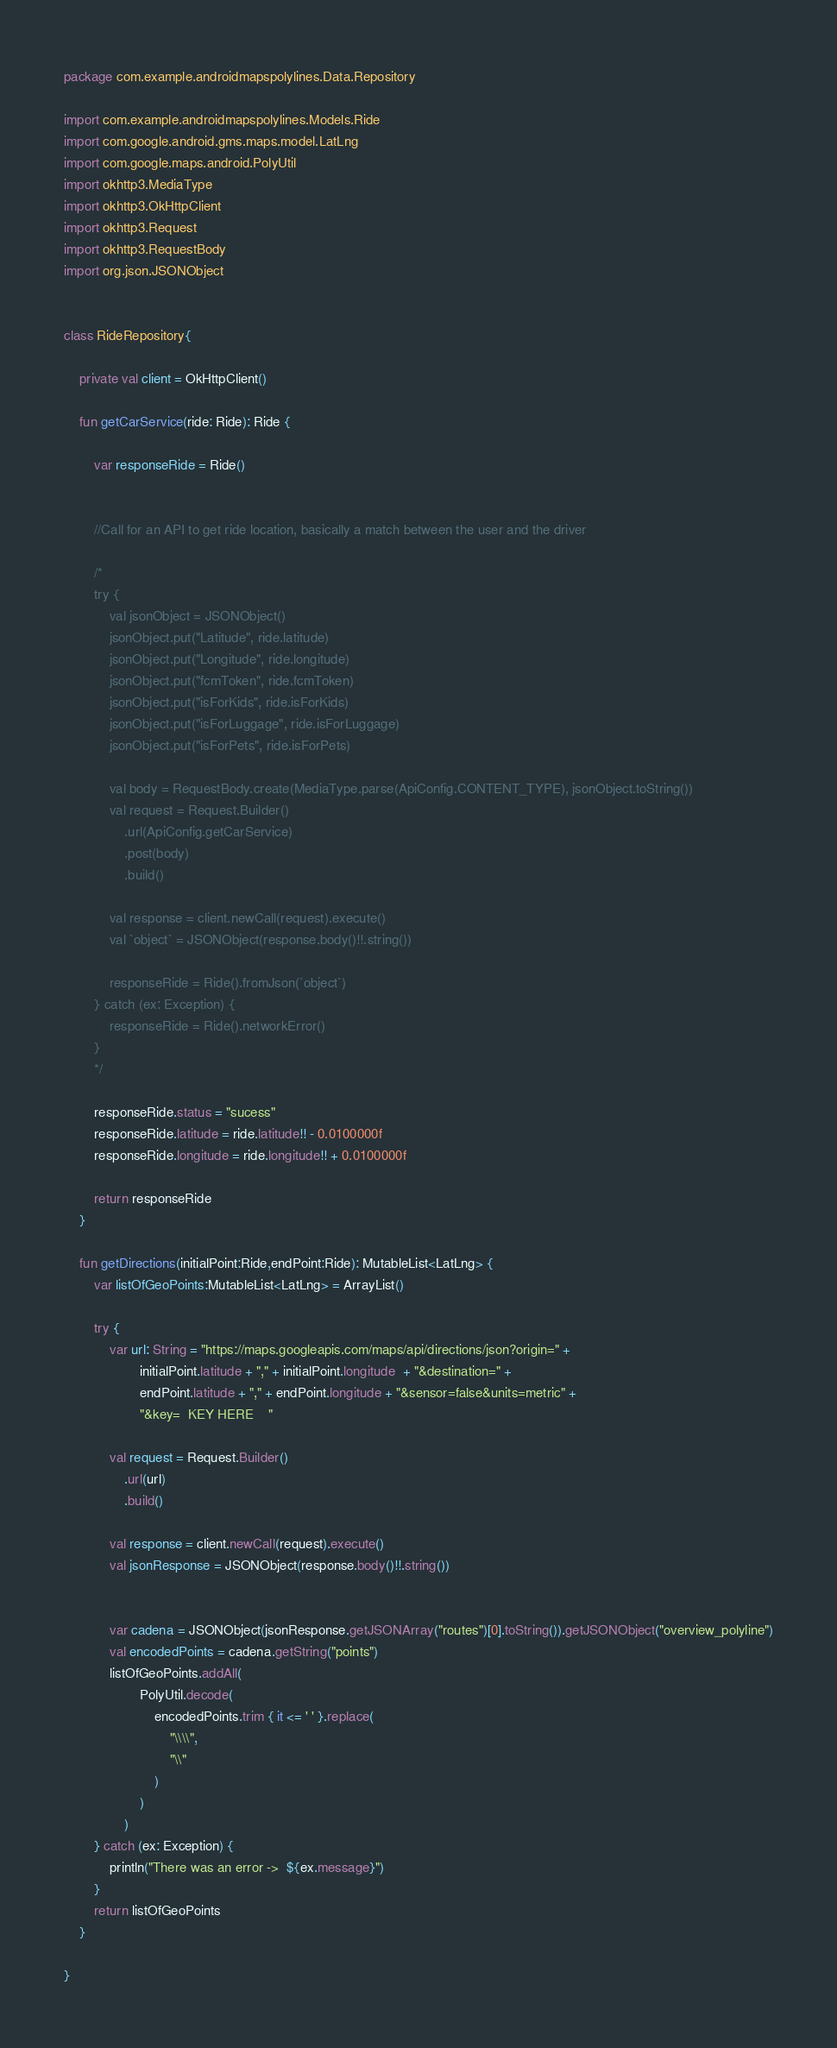<code> <loc_0><loc_0><loc_500><loc_500><_Kotlin_>package com.example.androidmapspolylines.Data.Repository

import com.example.androidmapspolylines.Models.Ride
import com.google.android.gms.maps.model.LatLng
import com.google.maps.android.PolyUtil
import okhttp3.MediaType
import okhttp3.OkHttpClient
import okhttp3.Request
import okhttp3.RequestBody
import org.json.JSONObject


class RideRepository{

    private val client = OkHttpClient()

    fun getCarService(ride: Ride): Ride {

        var responseRide = Ride()


        //Call for an API to get ride location, basically a match between the user and the driver

        /*
        try {
            val jsonObject = JSONObject()
            jsonObject.put("Latitude", ride.latitude)
            jsonObject.put("Longitude", ride.longitude)
            jsonObject.put("fcmToken", ride.fcmToken)
            jsonObject.put("isForKids", ride.isForKids)
            jsonObject.put("isForLuggage", ride.isForLuggage)
            jsonObject.put("isForPets", ride.isForPets)

            val body = RequestBody.create(MediaType.parse(ApiConfig.CONTENT_TYPE), jsonObject.toString())
            val request = Request.Builder()
                .url(ApiConfig.getCarService)
                .post(body)
                .build()

            val response = client.newCall(request).execute()
            val `object` = JSONObject(response.body()!!.string())

            responseRide = Ride().fromJson(`object`)
        } catch (ex: Exception) {
            responseRide = Ride().networkError()
        }
        */

        responseRide.status = "sucess"
        responseRide.latitude = ride.latitude!! - 0.0100000f
        responseRide.longitude = ride.longitude!! + 0.0100000f

        return responseRide
    }

    fun getDirections(initialPoint:Ride,endPoint:Ride): MutableList<LatLng> {
        var listOfGeoPoints:MutableList<LatLng> = ArrayList()

        try {
            var url: String = "https://maps.googleapis.com/maps/api/directions/json?origin=" +
                    initialPoint.latitude + "," + initialPoint.longitude  + "&destination=" +
                    endPoint.latitude + "," + endPoint.longitude + "&sensor=false&units=metric" +
                    "&key=  KEY HERE    "

            val request = Request.Builder()
                .url(url)
                .build()

            val response = client.newCall(request).execute()
            val jsonResponse = JSONObject(response.body()!!.string())


            var cadena = JSONObject(jsonResponse.getJSONArray("routes")[0].toString()).getJSONObject("overview_polyline")
            val encodedPoints = cadena.getString("points")
            listOfGeoPoints.addAll(
                    PolyUtil.decode(
                        encodedPoints.trim { it <= ' ' }.replace(
                            "\\\\",
                            "\\"
                        )
                    )
                )
        } catch (ex: Exception) {
            println("There was an error ->  ${ex.message}")
        }
        return listOfGeoPoints
    }

}</code> 